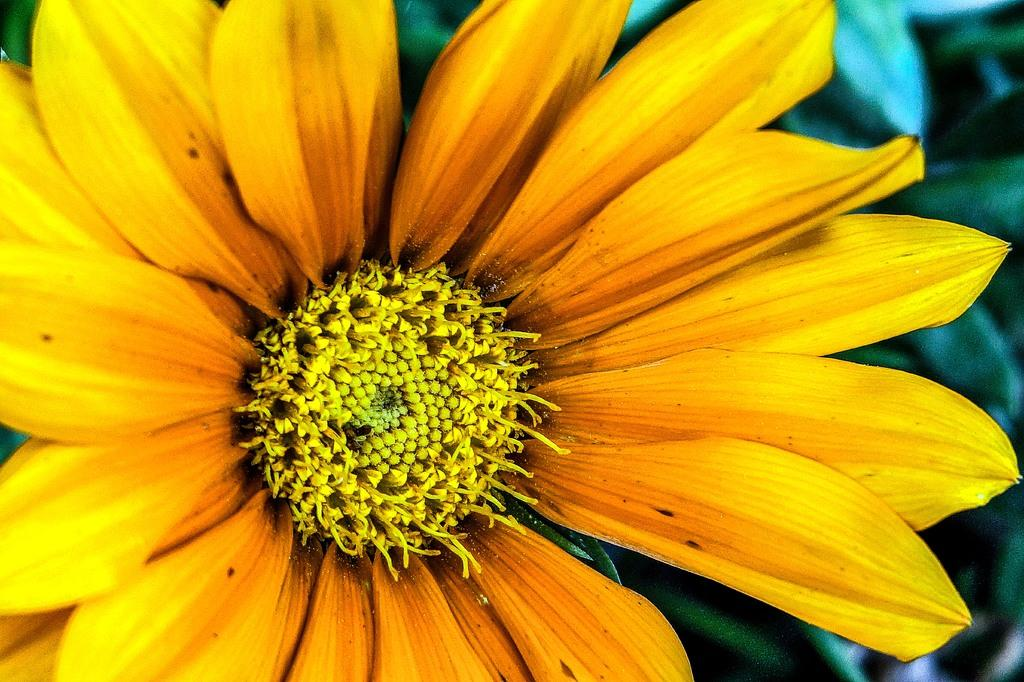What is the main subject of the picture? The main subject of the picture is a flower. What color are the petals of the flower? The petals of the flower have a yellow color. What else can be seen in the picture besides the flower? There are leaves visible behind the flower. How many loaves of bread can be seen in the picture? There are no loaves of bread present in the picture; it features a flower with yellow petals and leaves behind it. What type of ring is visible on the flower's stem? There is no ring present on the flower's stem in the picture. 